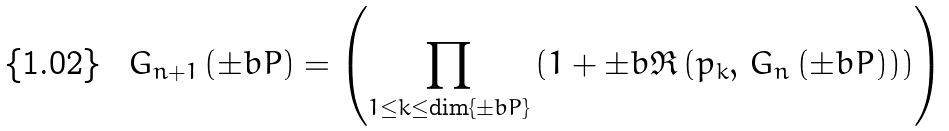<formula> <loc_0><loc_0><loc_500><loc_500>G _ { n + 1 } \left ( \pm b { P } \right ) = \left ( \prod _ { 1 \leq k \leq \dim \{ \pm b { P } \} } \left ( 1 + \pm b { \mathfrak { R } } \left ( p _ { k } , \, G _ { n } \left ( \pm b { P } \right ) \right ) \right ) \right )</formula> 